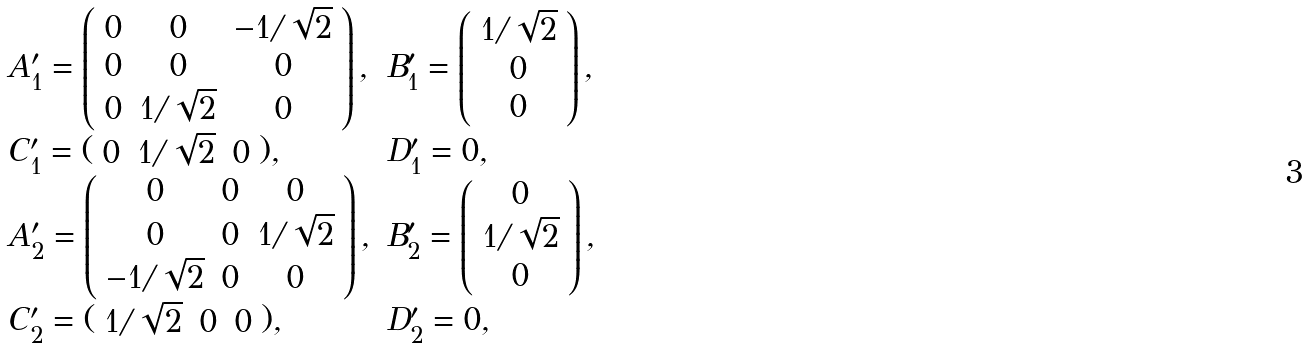Convert formula to latex. <formula><loc_0><loc_0><loc_500><loc_500>\begin{array} { l l } A _ { 1 } ^ { \prime } = \left ( \begin{array} { c c c } 0 & 0 & - 1 / \sqrt { 2 } \\ 0 & 0 & 0 \\ 0 & 1 / \sqrt { 2 } & 0 \end{array} \right ) , & B _ { 1 } ^ { \prime } = \left ( \begin{array} { c } 1 / \sqrt { 2 } \\ 0 \\ 0 \end{array} \right ) , \\ C _ { 1 } ^ { \prime } = ( \begin{array} { c c c } 0 & 1 / \sqrt { 2 } & 0 \end{array} ) , & D _ { 1 } ^ { \prime } = 0 , \\ A _ { 2 } ^ { \prime } = \left ( \begin{array} { c c c } 0 & 0 & 0 \\ 0 & 0 & 1 / \sqrt { 2 } \\ - 1 / \sqrt { 2 } & 0 & 0 \end{array} \right ) , & B _ { 2 } ^ { \prime } = \left ( \begin{array} { c } 0 \\ 1 / \sqrt { 2 } \\ 0 \end{array} \right ) , \\ C _ { 2 } ^ { \prime } = ( \begin{array} { c c c } 1 / \sqrt { 2 } & 0 & 0 \end{array} ) , & D _ { 2 } ^ { \prime } = 0 , \end{array}</formula> 